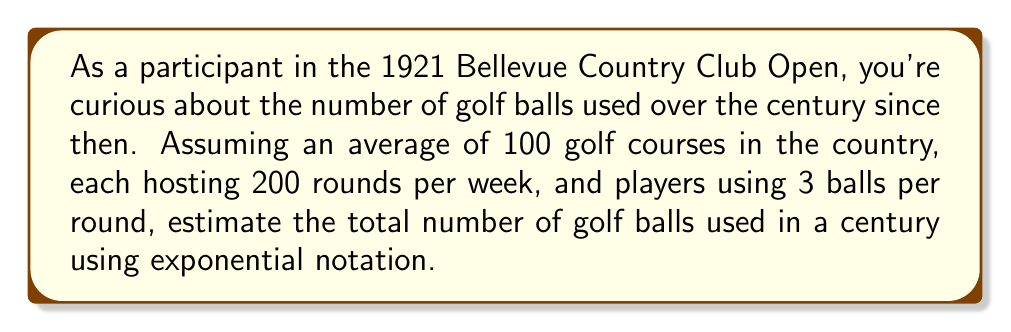Can you answer this question? Let's break this down step-by-step:

1) First, calculate the number of golf balls used per week:
   $100 \text{ courses} \times 200 \text{ rounds/course} \times 3 \text{ balls/round} = 60,000 \text{ balls/week}$

2) Now, calculate the number of golf balls used per year:
   $60,000 \text{ balls/week} \times 52 \text{ weeks/year} = 3,120,000 \text{ balls/year}$

3) To find the number of golf balls used in a century:
   $3,120,000 \text{ balls/year} \times 100 \text{ years} = 312,000,000 \text{ balls}$

4) Express this in exponential notation:
   $312,000,000 = 3.12 \times 10^8$

Therefore, the estimated number of golf balls used in a century, expressed in exponential notation, is $3.12 \times 10^8$.
Answer: $3.12 \times 10^8$ 